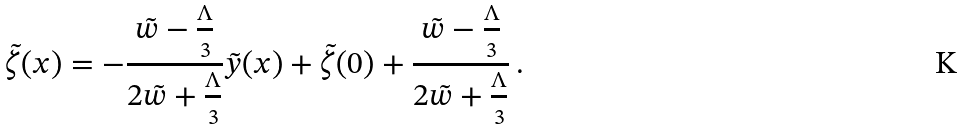<formula> <loc_0><loc_0><loc_500><loc_500>\tilde { \zeta } ( x ) = - \frac { \tilde { w } - \frac { \Lambda } { 3 } } { 2 \tilde { w } + \frac { \Lambda } { 3 } } \tilde { y } ( x ) + \tilde { \zeta } ( 0 ) + \frac { \tilde { w } - \frac { \Lambda } { 3 } } { 2 \tilde { w } + \frac { \Lambda } { 3 } } \, .</formula> 